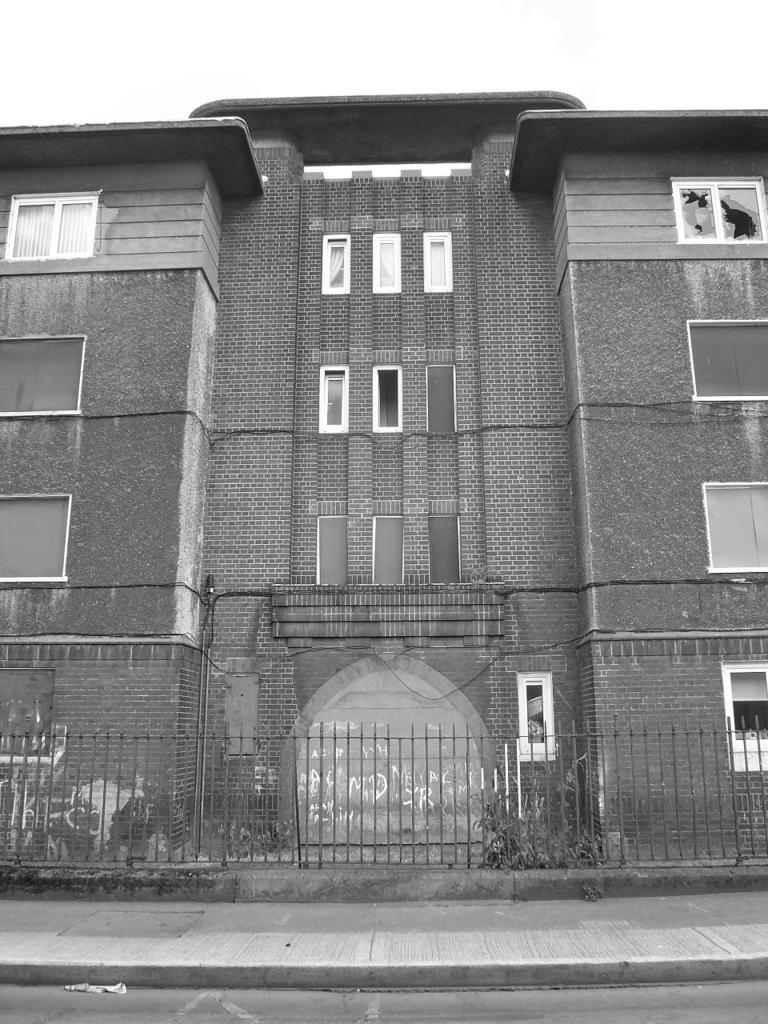What is the color scheme of the image? The image is black and white. What type of structure can be seen in the image? There is a building in the image. What feature is present near the building? There is railing in the image. What can be seen at the bottom of the image? There is a road and a footpath at the bottom of the image. Where is the boundary between the road and the footpath in the image? There is no specific boundary between the road and the footpath visible in the image; they are distinct but adjacent elements. How many people are sleeping on the footpath in the image? There are no people present in the image, let alone sleeping on the footpath. 